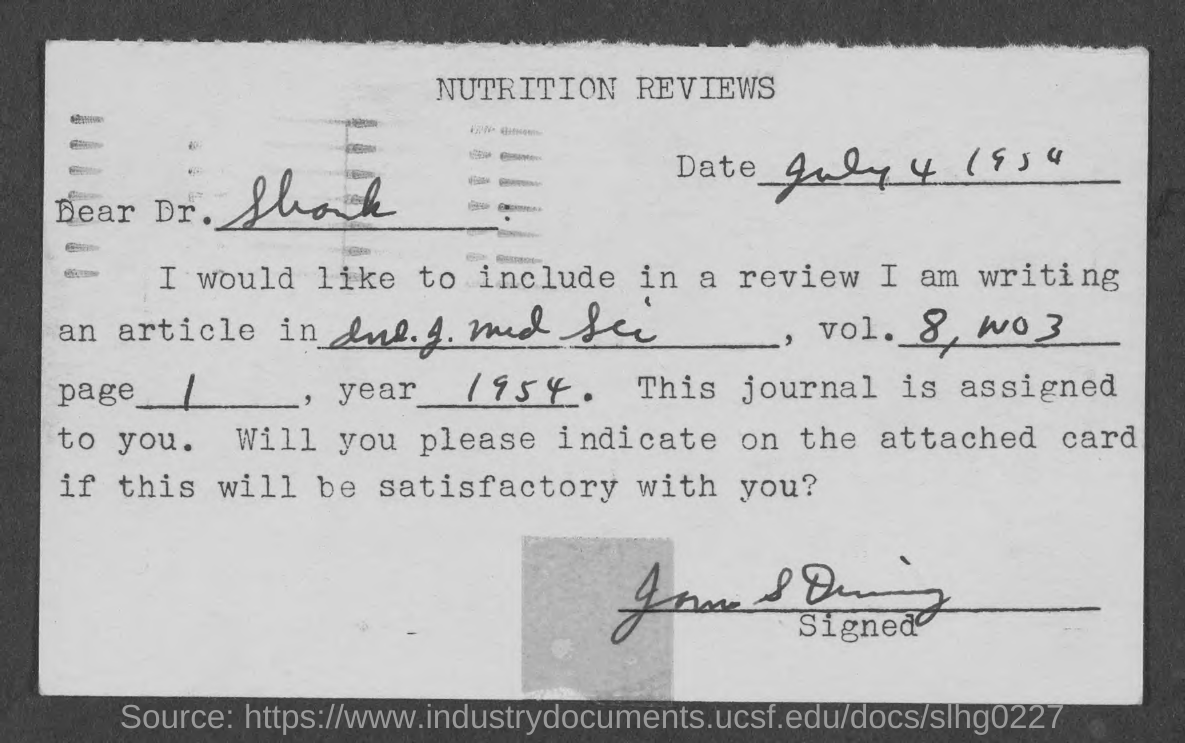Draw attention to some important aspects in this diagram. I want to know the page number of the book, specifically the one starting from 1 and ending with a period. The Memorandum was dated on July 4, 1954. The year 1954 was written in the year field. The title of the document is 'Nutrition Reviews'. 